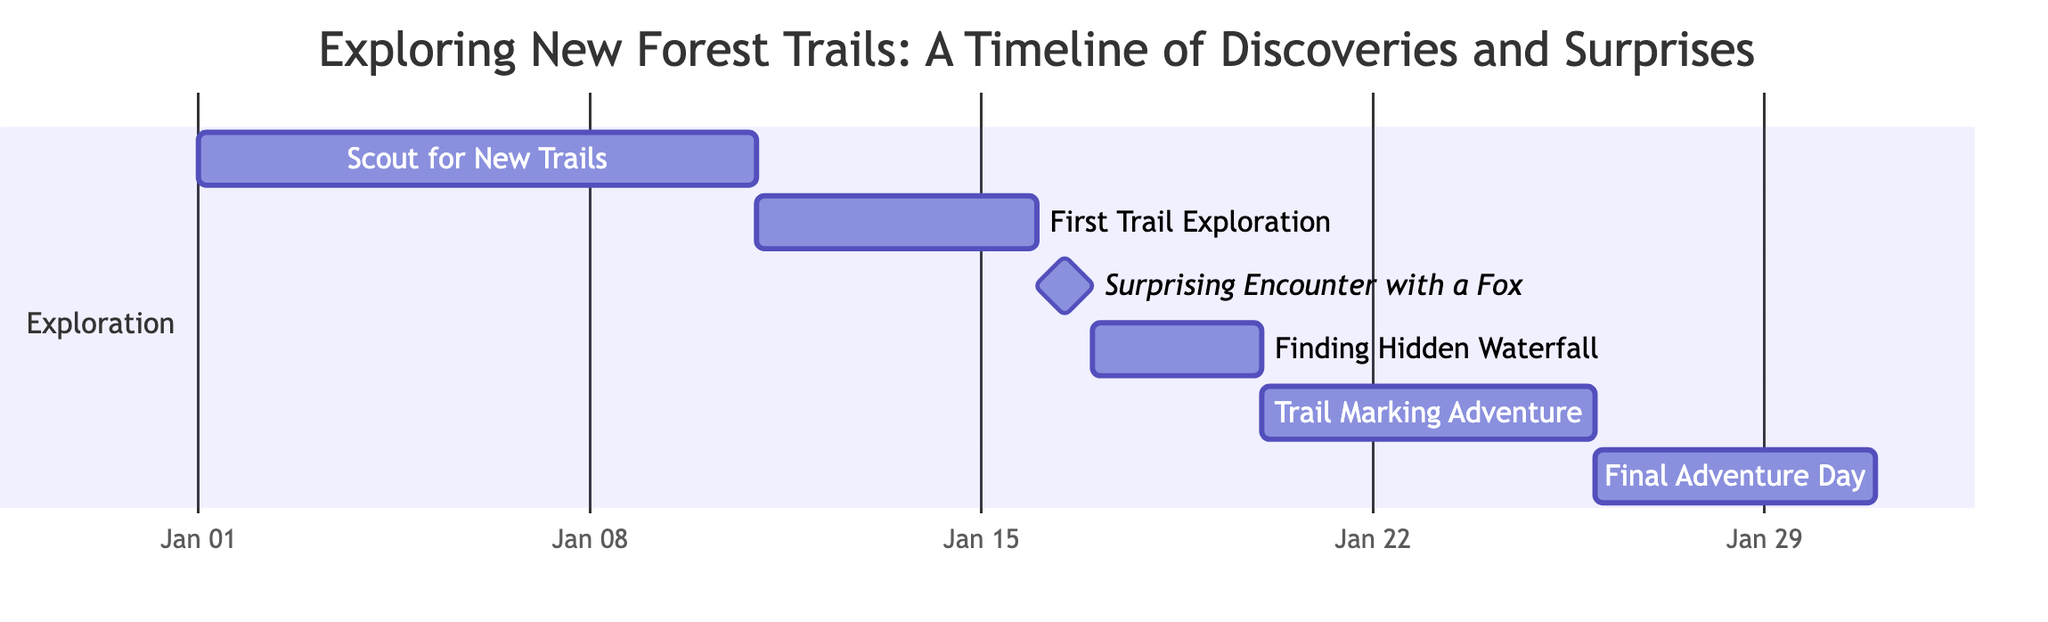What is the total number of tasks in this Gantt chart? The diagram lists six tasks: Scout for New Trails, First Trail Exploration, Surprising Encounter with a Fox, Finding Hidden Waterfall, Trail Marking Adventure, and Final Adventure Day. Count these tasks to determine the total.
Answer: 6 What is the duration of the "Finding Hidden Waterfall" task? The "Finding Hidden Waterfall" task starts on January 17 and ends on January 19. This indicates a duration of three days (January 17, 18, and 19).
Answer: 3 days On what date does the "Surprising Encounter with a Fox" occur? This task is marked clearly as a milestone occurring specifically on January 16, as stated in the task description in the diagram.
Answer: January 16 Which task follows the "First Trail Exploration"? According to the diagram, the task that follows "First Trail Exploration" is "Surprising Encounter with a Fox," occurring immediately after January 15 on January 16.
Answer: Surprising Encounter with a Fox How long does the "Trail Marking Adventure" last? The "Trail Marking Adventure" starts on January 20 and ends on January 25, which means it lasts for six days (January 20, 21, 22, 23, 24, and 25).
Answer: 6 days What is the earliest task in the timeline? The earliest task is "Scout for New Trails," which starts on January 1, 2023. It is the first task listed in the Gantt chart.
Answer: Scout for New Trails What are the dates for the "Final Adventure Day"? The diagram shows that the "Final Adventure Day" begins on January 26 and concludes on January 30, indicating these exact dates.
Answer: January 26 to January 30 Which task is a milestone in the chart? The "Surprising Encounter with a Fox" is specifically indicated as a milestone in the Gantt chart, meaning it represents a significant point in the timeline.
Answer: Surprising Encounter with a Fox 